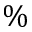Convert formula to latex. <formula><loc_0><loc_0><loc_500><loc_500>\%</formula> 